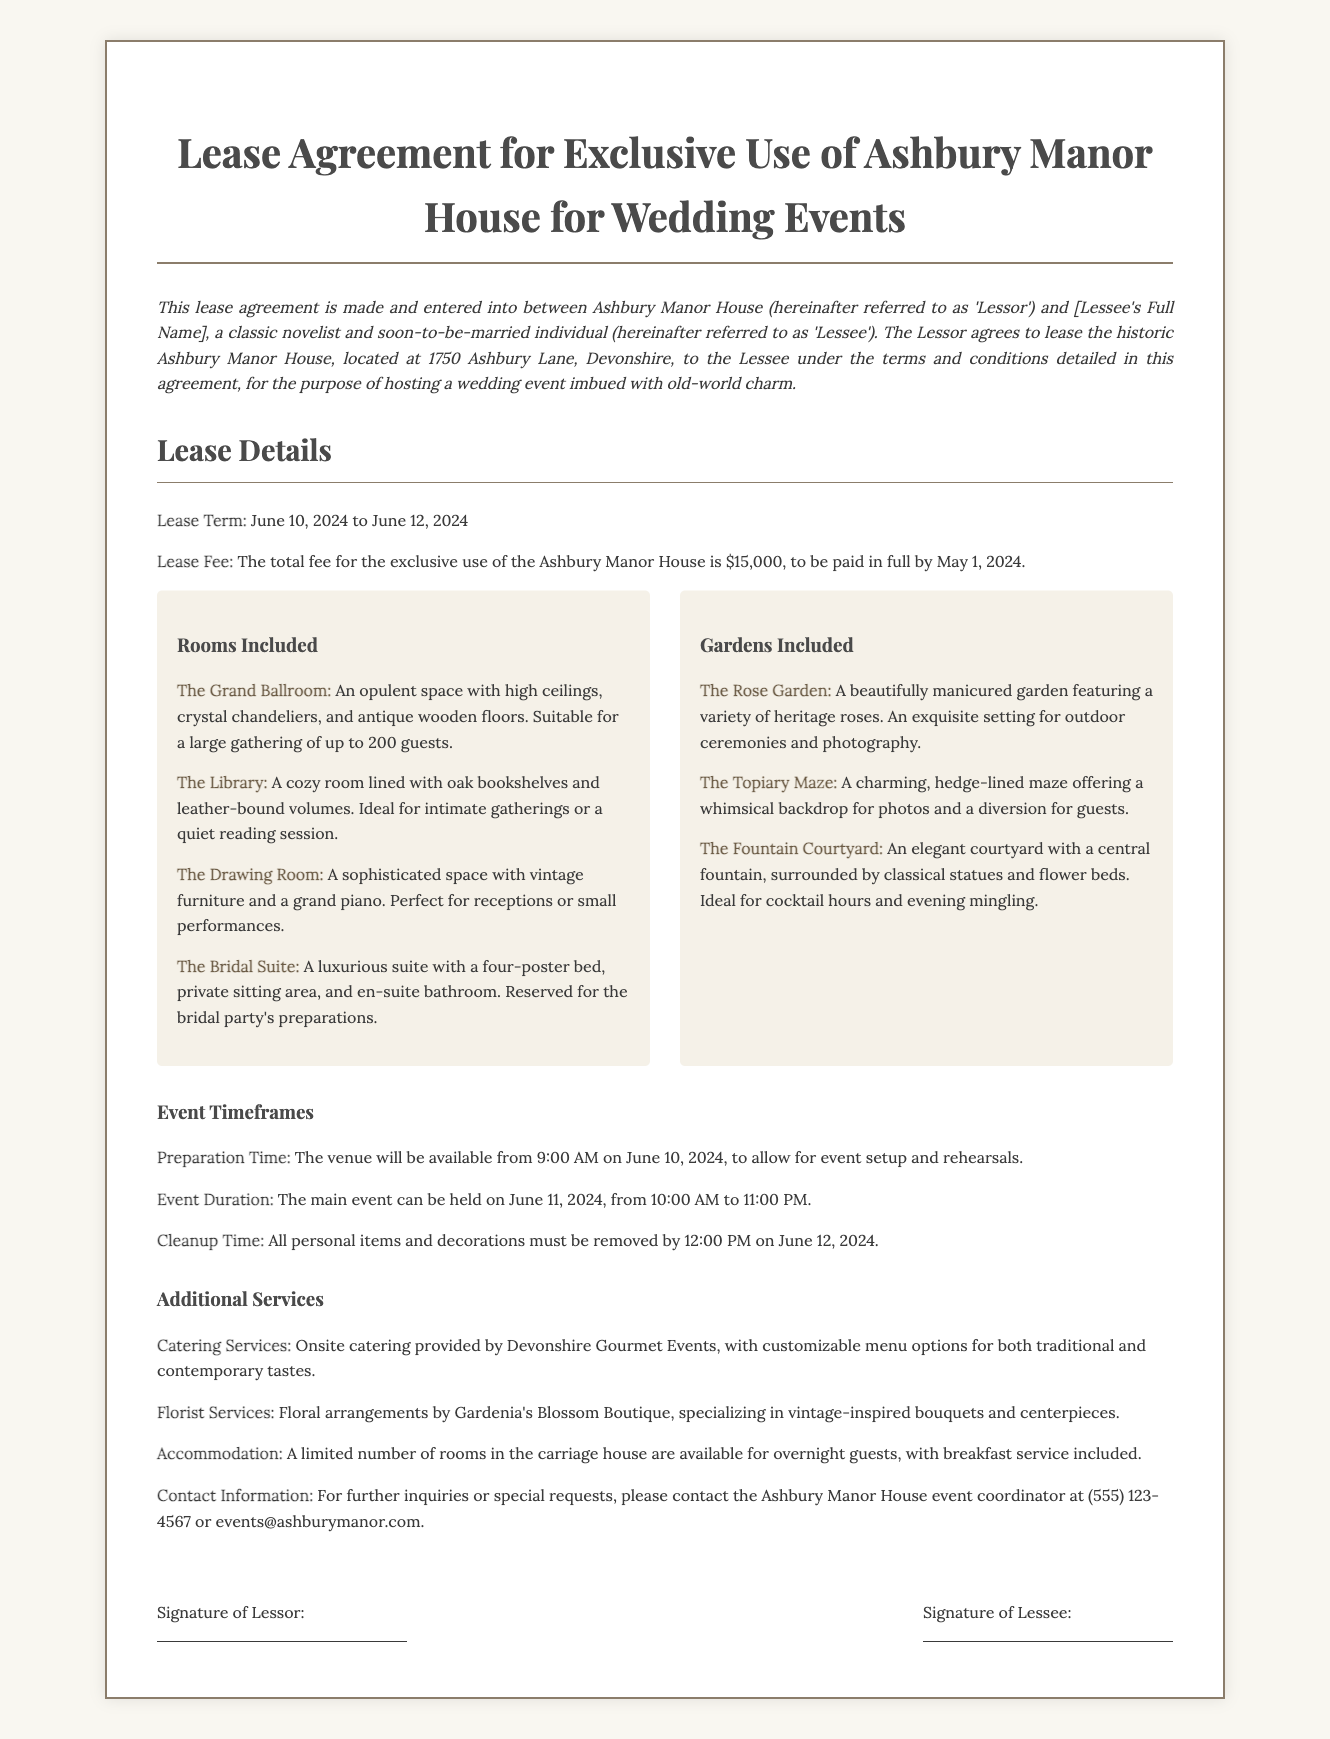What is the lease fee for Ashbury Manor House? The lease fee is specified in the document as the total amount for the exclusive use of the venue.
Answer: $15,000 What are the event preparation hours? The preparation time indicates when the venue becomes available for setup and rehearsals according to the document.
Answer: 9:00 AM What is the maximum guest capacity for The Grand Ballroom? The maximum guest capacity is listed as the number of guests that can be accommodated in that specific room.
Answer: 200 guests On which date can the main event be held? The document specifies the date for the main event within the timeframe of the lease agreement.
Answer: June 11, 2024 What is included in the catering services? The document describes the type of service provided for catering and the company responsible for it.
Answer: Devonshire Gourmet Events What is the last time personal items must be removed? This refers to the deadline for cleanup and removal of belongings after the event, as outlined in the agreement.
Answer: 12:00 PM Which room is reserved for the bridal party's preparations? The document lists specific rooms, one of which is designated for the bridal party.
Answer: The Bridal Suite What floral arrangement service is mentioned in the agreement? The document identifies a specific floral service available for the wedding event.
Answer: Gardenia's Blossom Boutique 